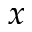<formula> <loc_0><loc_0><loc_500><loc_500>x</formula> 